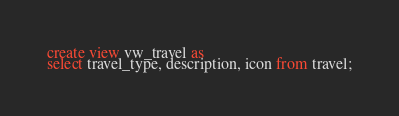<code> <loc_0><loc_0><loc_500><loc_500><_SQL_>
create view vw_travel as
select travel_type, description, icon from travel;</code> 